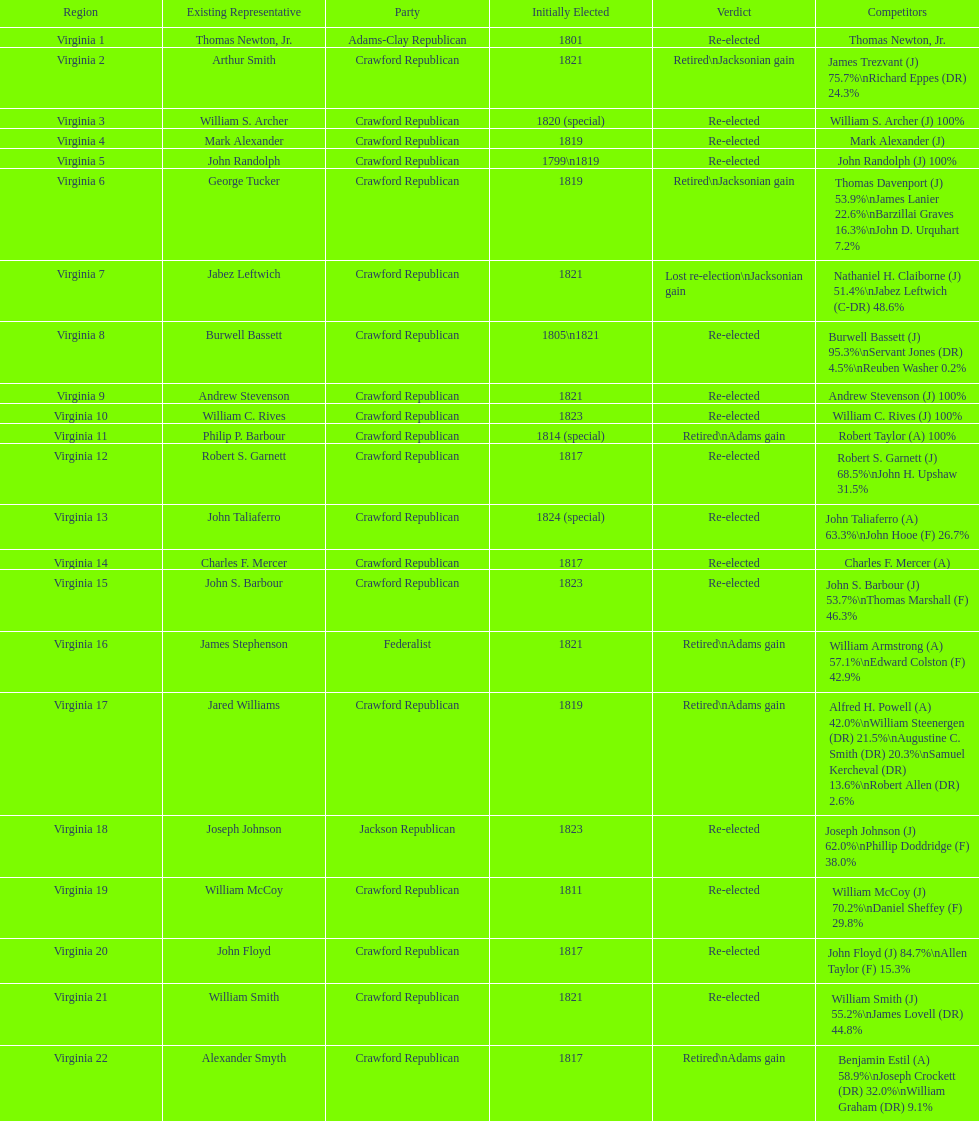What is the last party on this chart? Crawford Republican. 